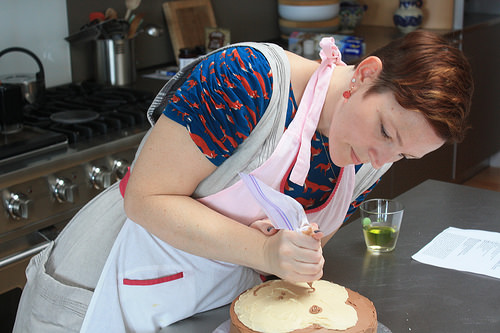<image>
Is there a sugar bowl above the cake? No. The sugar bowl is not positioned above the cake. The vertical arrangement shows a different relationship. 